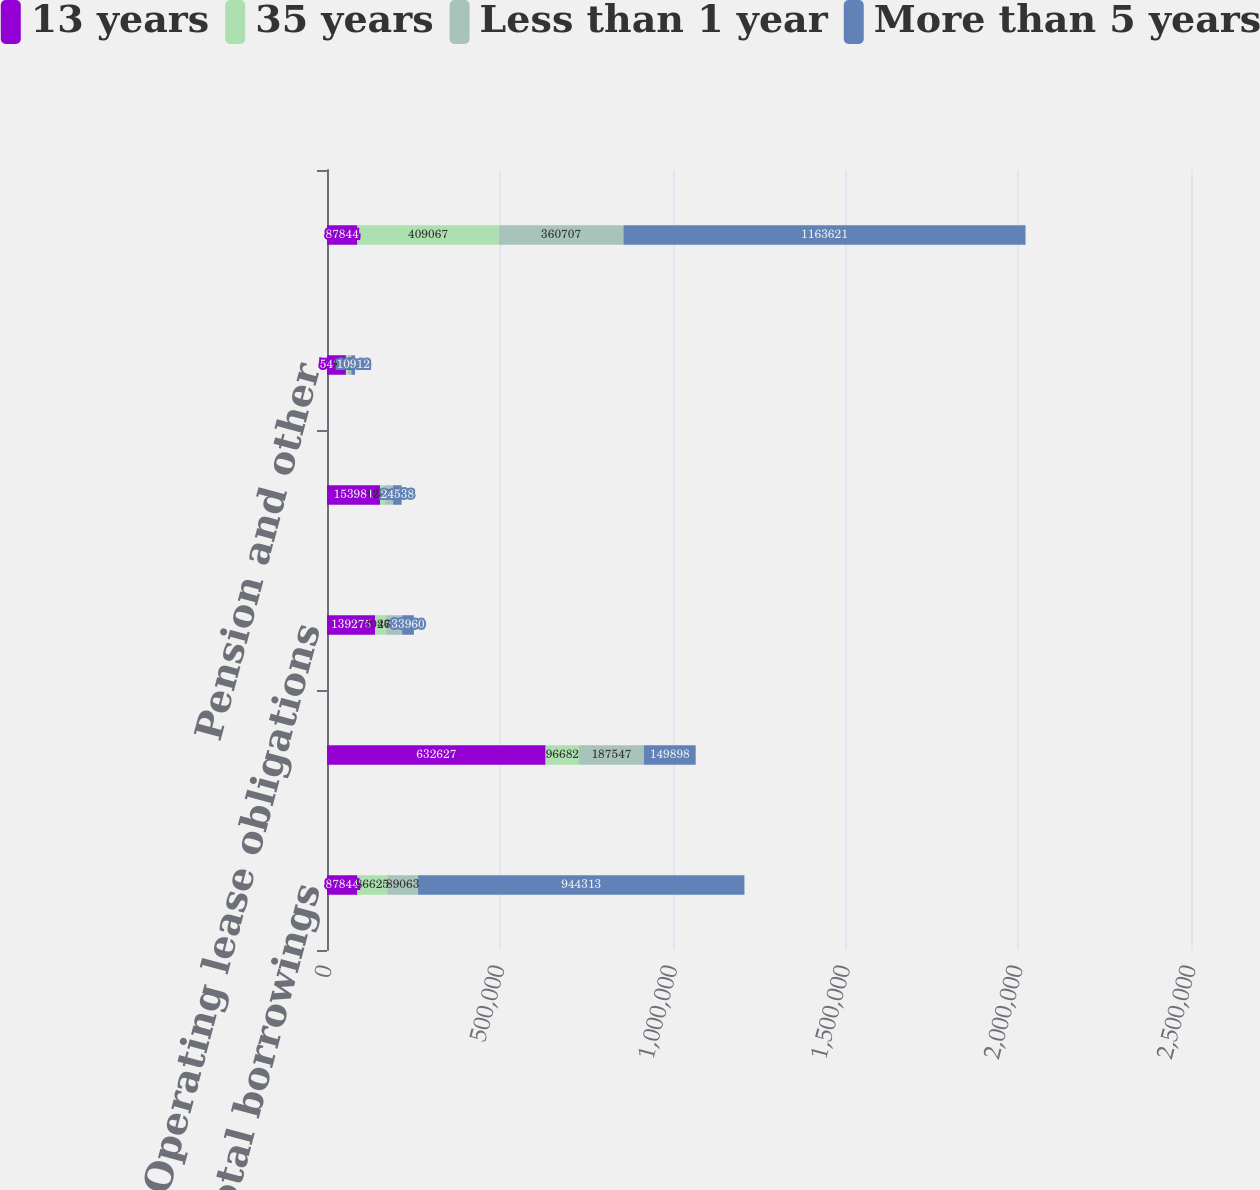Convert chart. <chart><loc_0><loc_0><loc_500><loc_500><stacked_bar_chart><ecel><fcel>Total borrowings<fcel>Interest obligations(1)<fcel>Operating lease obligations<fcel>Tax on deemed repatriation of<fcel>Pension and other<fcel>Total contractual obligations<nl><fcel>13 years<fcel>87844<fcel>632627<fcel>139275<fcel>153981<fcel>54792<fcel>87844<nl><fcel>35 years<fcel>86625<fcel>96682<fcel>30262<fcel>12887<fcel>5073<fcel>409067<nl><fcel>Less than 1 year<fcel>89063<fcel>187547<fcel>47886<fcel>24538<fcel>10419<fcel>360707<nl><fcel>More than 5 years<fcel>944313<fcel>149898<fcel>33960<fcel>24538<fcel>10912<fcel>1.16362e+06<nl></chart> 